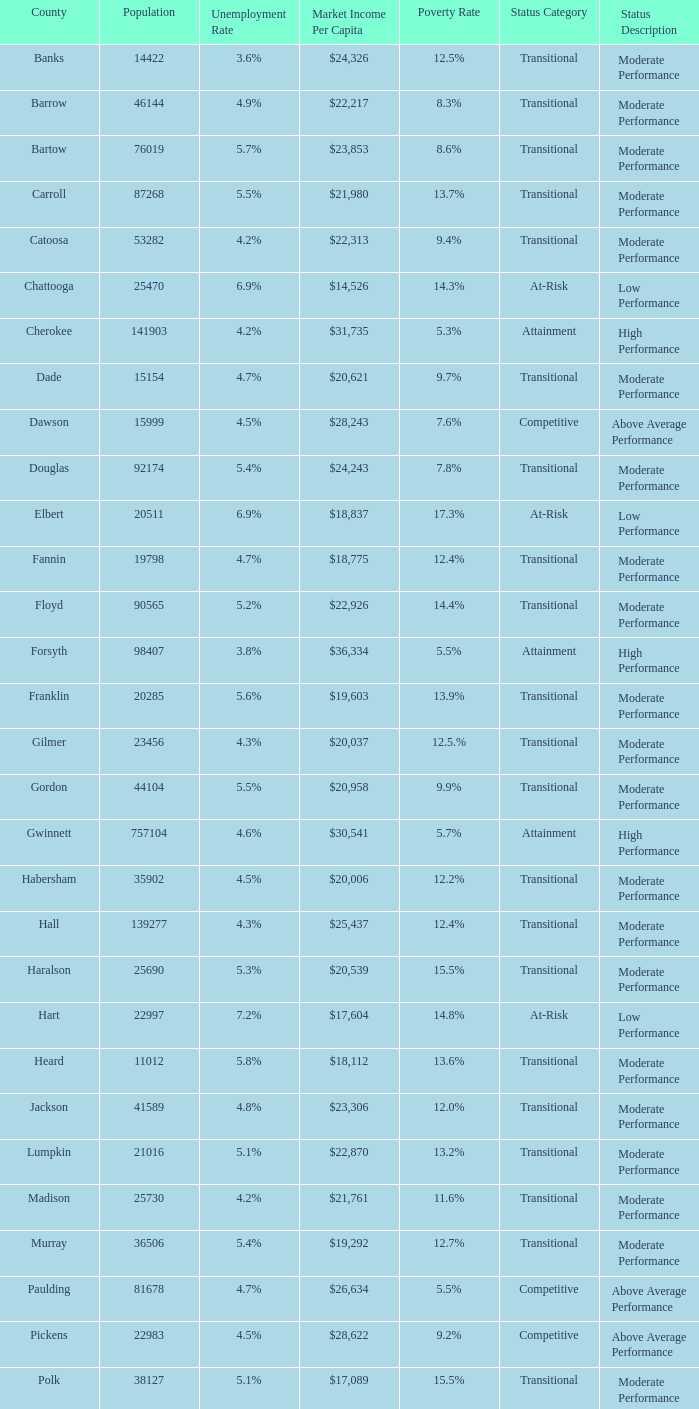What is the status of the county that has a 17.3% poverty rate? At-Risk. 